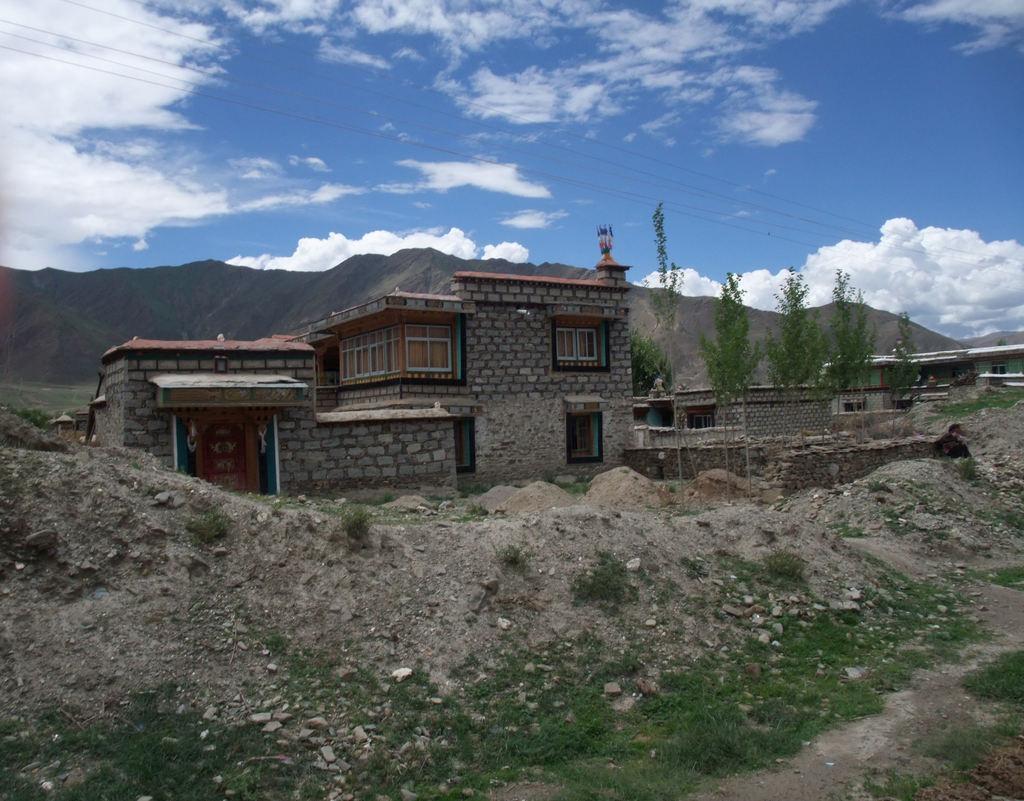Describe this image in one or two sentences. In this image in front there is sand. In the center of the image there are buildings, trees. In the background of the image there are mountains and sky. 